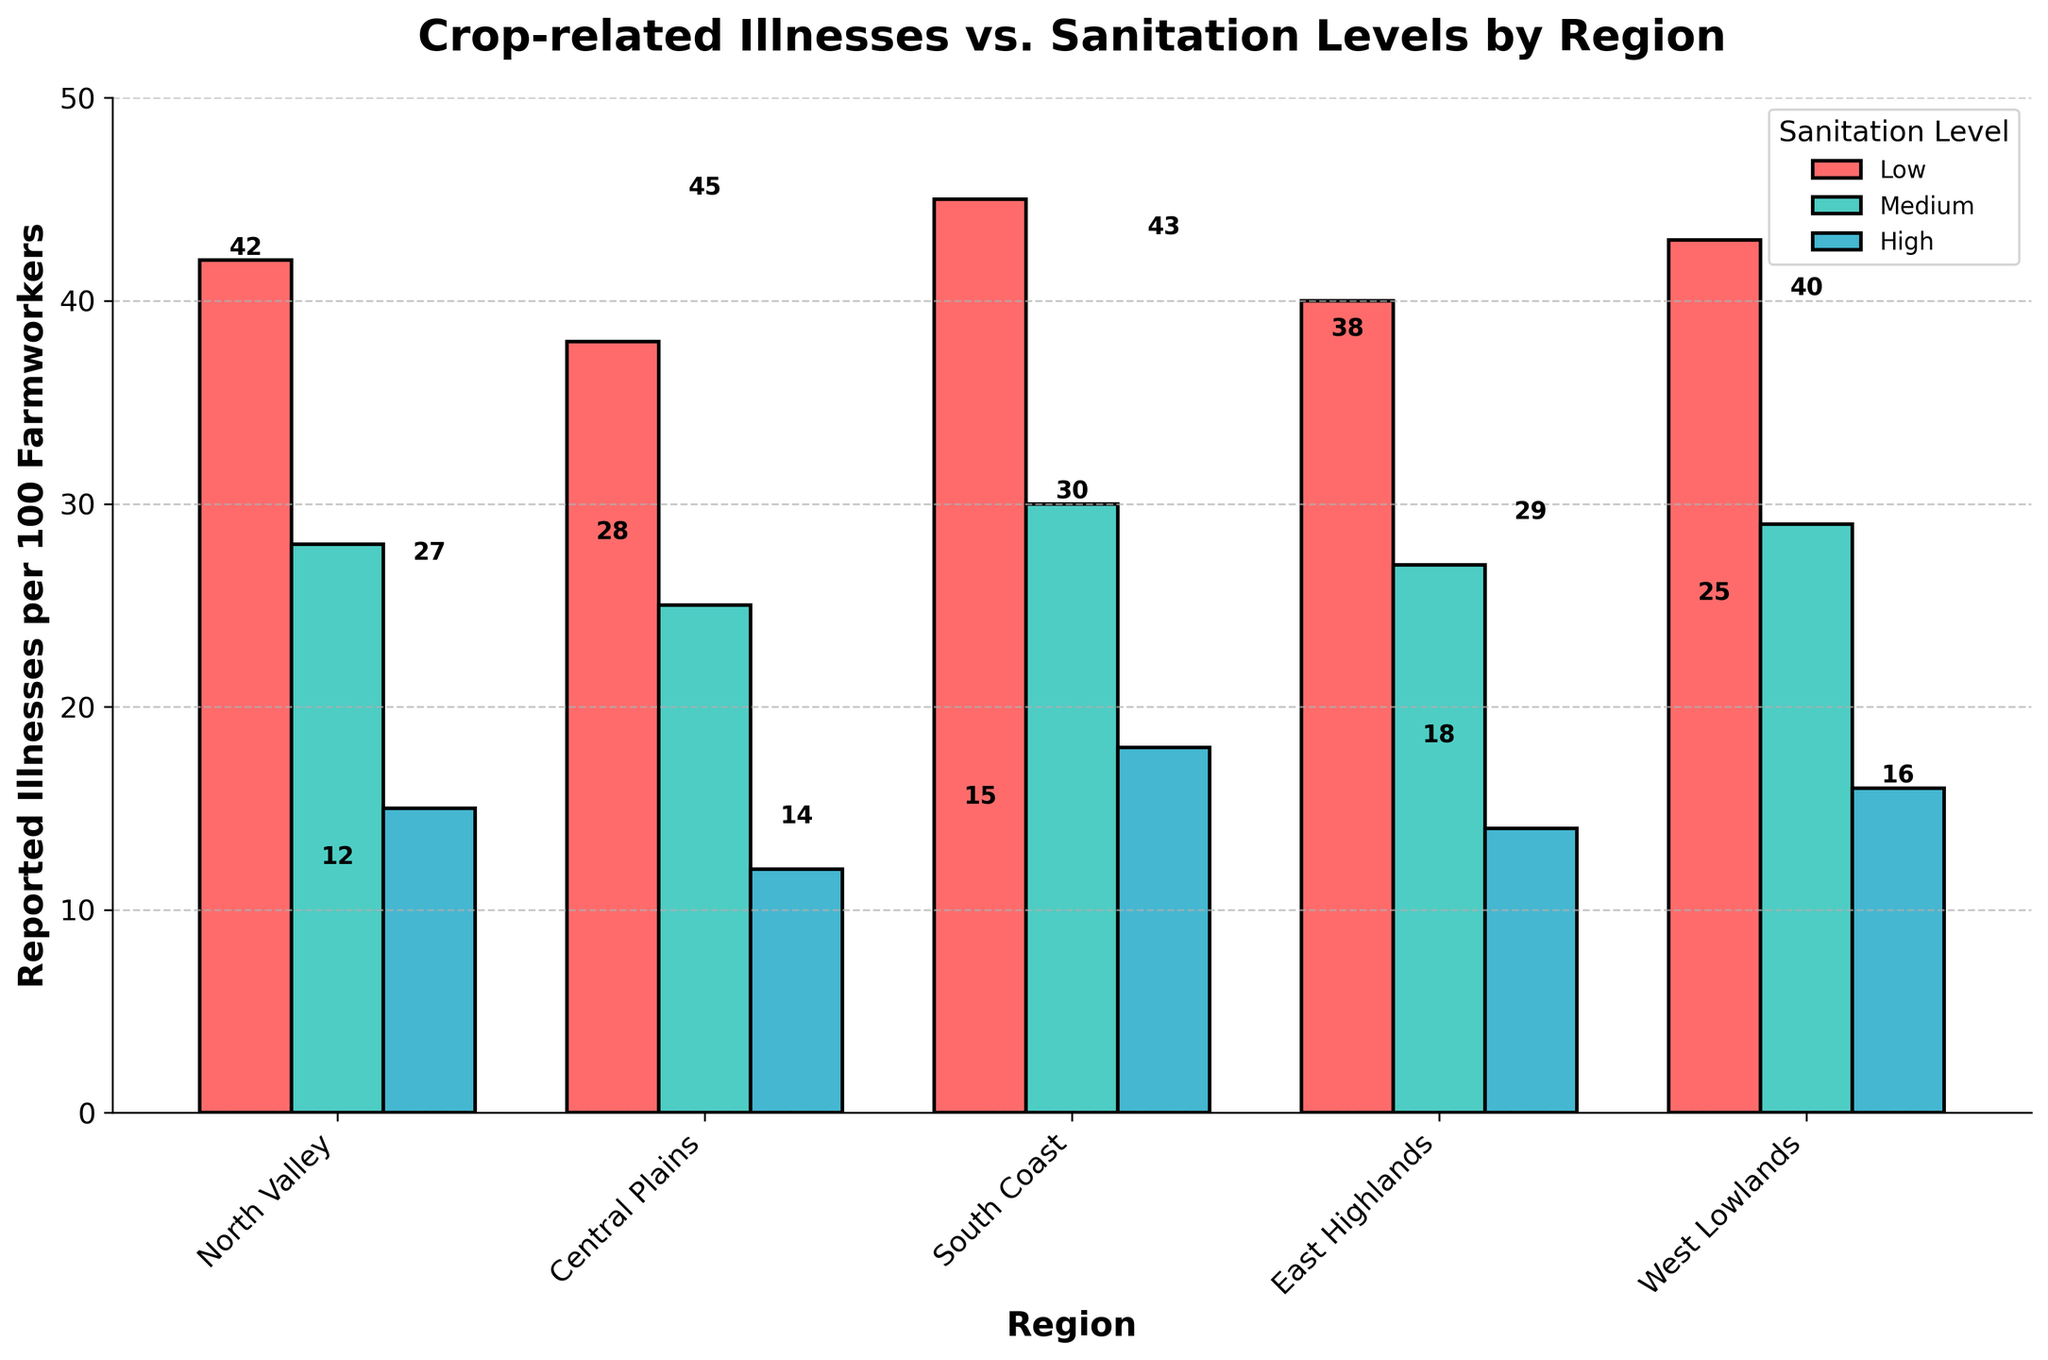what is the range of reported illnesses per 100 farmworkers in the North Valley region? In the North Valley region, the reported illnesses range from 42 for low sanitation, 28 for medium sanitation, to 15 for high sanitation. The range can be calculated as the difference between the maximum and minimum values: 42 - 15 = 27
Answer: 27 which region shows the highest number of reported illnesses for low sanitation levels? For low sanitation levels, the regions show the following numbers of reported illnesses: North Valley (42), Central Plains (38), South Coast (45), East Highlands (40), and West Lowlands (43). The highest number is South Coast with 45
Answer: South Coast calculate the average number of reported illnesses in the Central Plains for each sanitation level The numbers of reported illnesses in the Central Plains are 38 for low, 25 for medium, and 12 for high sanitation levels. The average can be calculated by summing up these values and dividing by the number of levels: (38 + 25 + 12) / 3 = 75 / 3 = 25
Answer: 25 which region's medium sanitation level has the closest number of reported illnesses to the high sanitation level of the North Valley? For medium sanitation levels, the regions report: North Valley (28), Central Plains (25), South Coast (30), East Highlands (27), and West Lowlands (29). North Valley's high sanitation level reports 15 illnesses. The closest number is from the Central Plains with 12. The difference is 28 - 15 = 13, 25 - 15 = 10, 30 - 15 = 15, 27 - 15 = 12, and 29 - 15 = 14. The smallest amongst these is 10 which is 25 - 15
Answer: Central Plains do all regions show a reduction in reported illnesses from low to high sanitation levels? By visually comparing the various levels across all regions: 
North Valley shows 42 (Low), 28 (Medium), 15 (High), 
Central Plains shows 38 (Low), 25 (Medium), 12 (High),
South Coast shows 45 (Low), 30 (Medium), 18 (High),
East Highlands shows 40 (Low), 27 (Medium), 14 (High), 
West Lowlands shows 43 (Low), 29 (Medium), 16 (High). 
Thus, all regions show a reduction from low to high.
Answer: Yes 